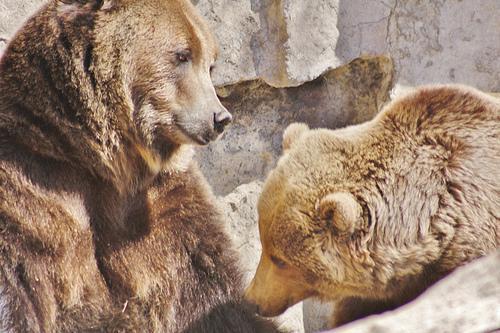How many bears are shown?
Give a very brief answer. 2. 